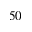<formula> <loc_0><loc_0><loc_500><loc_500>5 0</formula> 